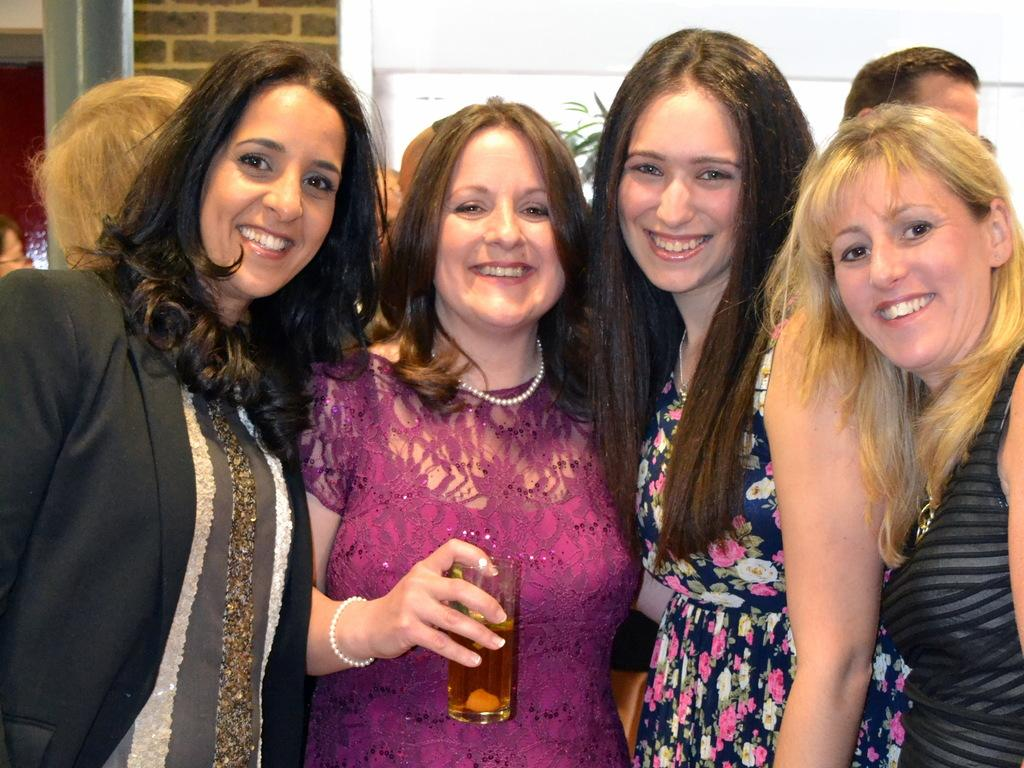How many women are in the image? There are four women standing and smiling in the image. What is one of the women holding? One of the women is holding a glass. Can you describe the background of the image? In the background, there are people standing and a pillar visible. There is also a wall visible in the background. What direction are the waves coming from in the image? There are no waves present in the image. 